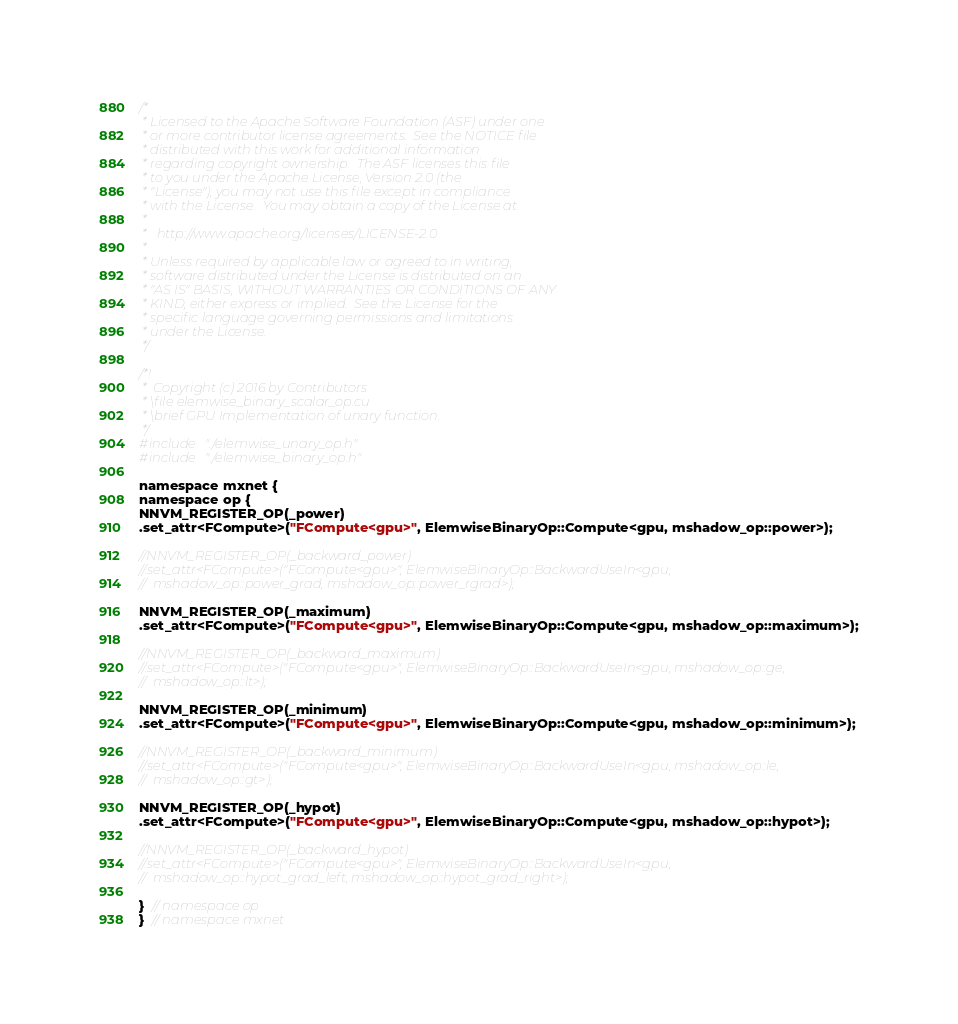<code> <loc_0><loc_0><loc_500><loc_500><_Cuda_>/*
 * Licensed to the Apache Software Foundation (ASF) under one
 * or more contributor license agreements.  See the NOTICE file
 * distributed with this work for additional information
 * regarding copyright ownership.  The ASF licenses this file
 * to you under the Apache License, Version 2.0 (the
 * "License"); you may not use this file except in compliance
 * with the License.  You may obtain a copy of the License at
 *
 *   http://www.apache.org/licenses/LICENSE-2.0
 *
 * Unless required by applicable law or agreed to in writing,
 * software distributed under the License is distributed on an
 * "AS IS" BASIS, WITHOUT WARRANTIES OR CONDITIONS OF ANY
 * KIND, either express or implied.  See the License for the
 * specific language governing permissions and limitations
 * under the License.
 */

/*!
 *  Copyright (c) 2016 by Contributors
 * \file elemwise_binary_scalar_op.cu
 * \brief GPU Implementation of unary function.
 */
#include "./elemwise_unary_op.h"
#include "./elemwise_binary_op.h"

namespace mxnet {
namespace op {
NNVM_REGISTER_OP(_power)
.set_attr<FCompute>("FCompute<gpu>", ElemwiseBinaryOp::Compute<gpu, mshadow_op::power>);

//NNVM_REGISTER_OP(_backward_power)
//.set_attr<FCompute>("FCompute<gpu>", ElemwiseBinaryOp::BackwardUseIn<gpu,
//  mshadow_op::power_grad, mshadow_op::power_rgrad>);

NNVM_REGISTER_OP(_maximum)
.set_attr<FCompute>("FCompute<gpu>", ElemwiseBinaryOp::Compute<gpu, mshadow_op::maximum>);

//NNVM_REGISTER_OP(_backward_maximum)
//.set_attr<FCompute>("FCompute<gpu>", ElemwiseBinaryOp::BackwardUseIn<gpu, mshadow_op::ge,
//  mshadow_op::lt>);

NNVM_REGISTER_OP(_minimum)
.set_attr<FCompute>("FCompute<gpu>", ElemwiseBinaryOp::Compute<gpu, mshadow_op::minimum>);

//NNVM_REGISTER_OP(_backward_minimum)
//.set_attr<FCompute>("FCompute<gpu>", ElemwiseBinaryOp::BackwardUseIn<gpu, mshadow_op::le,
//  mshadow_op::gt>);

NNVM_REGISTER_OP(_hypot)
.set_attr<FCompute>("FCompute<gpu>", ElemwiseBinaryOp::Compute<gpu, mshadow_op::hypot>);

//NNVM_REGISTER_OP(_backward_hypot)
//.set_attr<FCompute>("FCompute<gpu>", ElemwiseBinaryOp::BackwardUseIn<gpu,
//  mshadow_op::hypot_grad_left, mshadow_op::hypot_grad_right>);

}  // namespace op
}  // namespace mxnet
</code> 